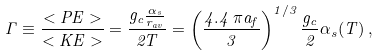Convert formula to latex. <formula><loc_0><loc_0><loc_500><loc_500>\Gamma \equiv \frac { < P E > } { < K E > } = \frac { g _ { c } \frac { \alpha _ { s } } { r _ { a v } } } { 2 T } = \left ( \frac { 4 . 4 \, \pi a _ { f } } { 3 } \right ) ^ { 1 / 3 } \frac { g _ { c } } { 2 } \alpha _ { s } ( T ) \, ,</formula> 